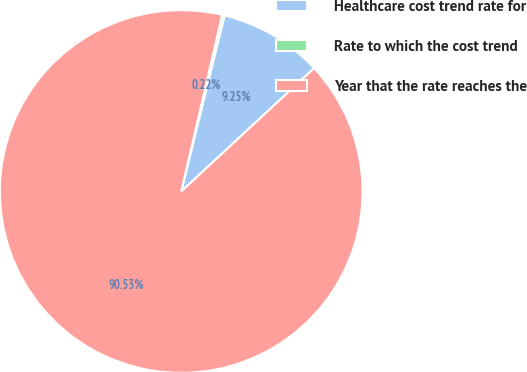<chart> <loc_0><loc_0><loc_500><loc_500><pie_chart><fcel>Healthcare cost trend rate for<fcel>Rate to which the cost trend<fcel>Year that the rate reaches the<nl><fcel>9.25%<fcel>0.22%<fcel>90.52%<nl></chart> 